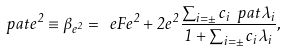<formula> <loc_0><loc_0><loc_500><loc_500>\ p a t e ^ { 2 } \equiv \beta _ { e ^ { 2 } } = \ e F e ^ { 2 } + 2 e ^ { 2 } \frac { \sum _ { i = \pm } c _ { i } \ p a t \lambda _ { i } } { 1 + \sum _ { i = \pm } c _ { i } \lambda _ { i } } ,</formula> 